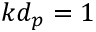Convert formula to latex. <formula><loc_0><loc_0><loc_500><loc_500>k d _ { p } = 1</formula> 